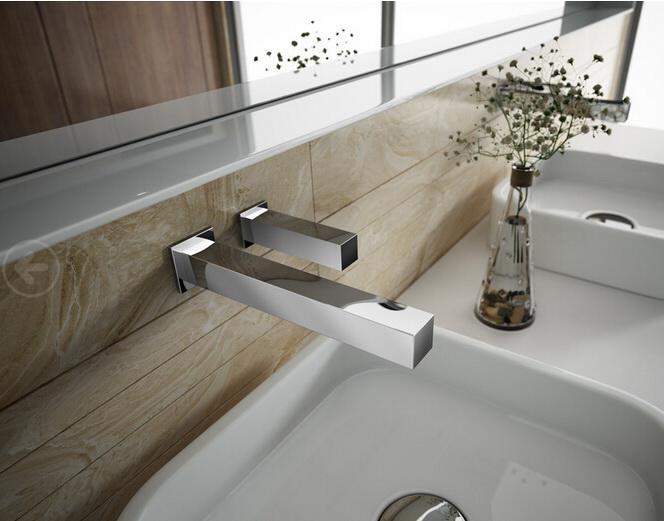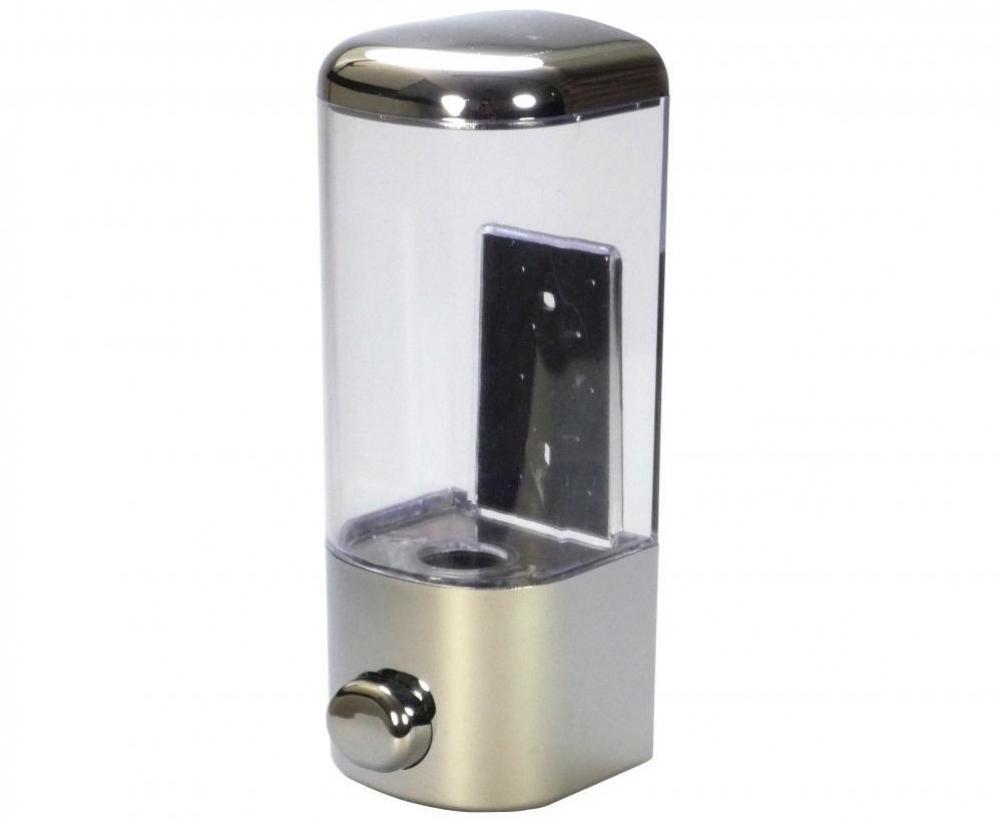The first image is the image on the left, the second image is the image on the right. Analyze the images presented: Is the assertion "there is a white square shaped sink with a chrome faucet and a vase of flowers next to it" valid? Answer yes or no. Yes. 